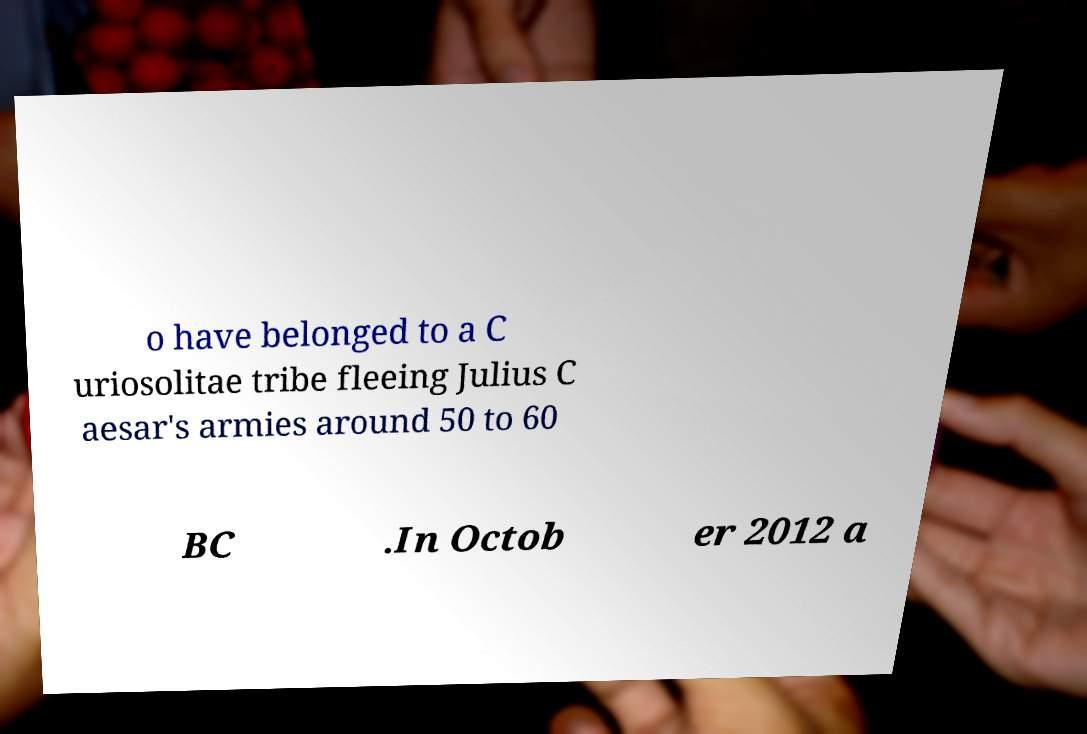Could you extract and type out the text from this image? o have belonged to a C uriosolitae tribe fleeing Julius C aesar's armies around 50 to 60 BC .In Octob er 2012 a 